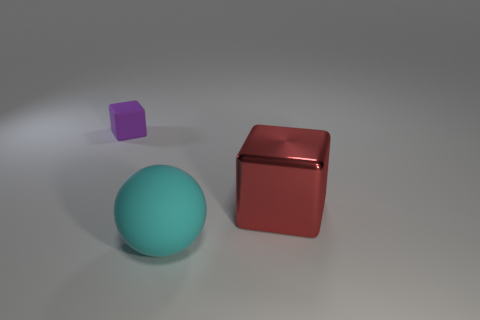Add 2 large cyan things. How many objects exist? 5 Subtract all spheres. How many objects are left? 2 Subtract 0 brown blocks. How many objects are left? 3 Subtract all red blocks. Subtract all rubber blocks. How many objects are left? 1 Add 3 big red metallic cubes. How many big red metallic cubes are left? 4 Add 2 large cyan balls. How many large cyan balls exist? 3 